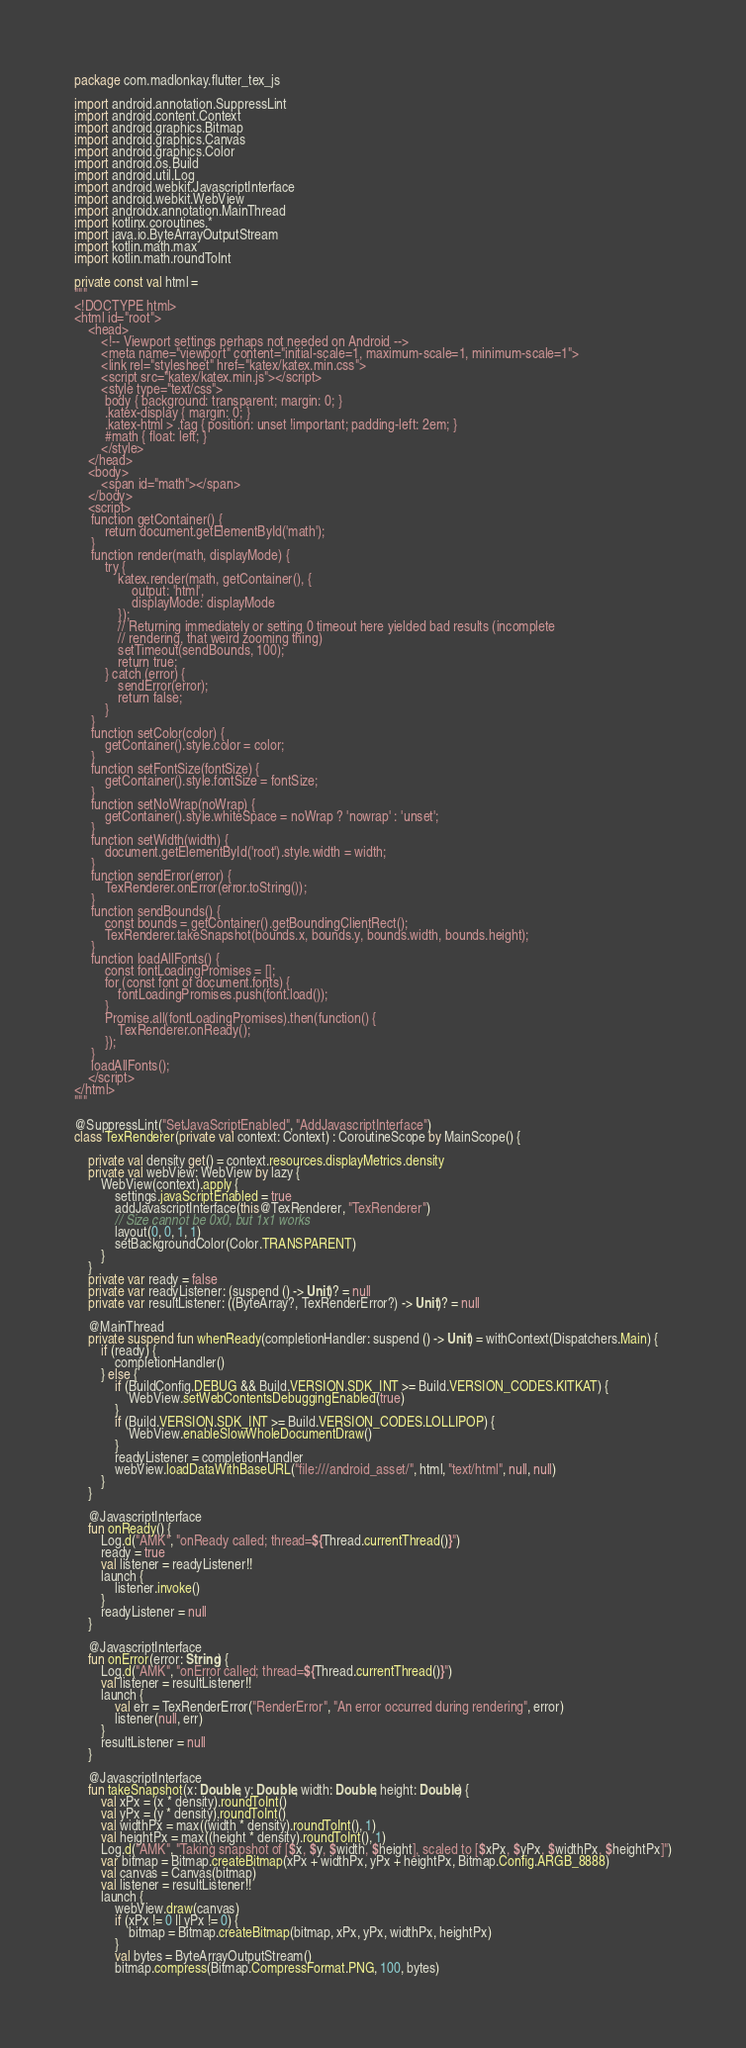<code> <loc_0><loc_0><loc_500><loc_500><_Kotlin_>package com.madlonkay.flutter_tex_js

import android.annotation.SuppressLint
import android.content.Context
import android.graphics.Bitmap
import android.graphics.Canvas
import android.graphics.Color
import android.os.Build
import android.util.Log
import android.webkit.JavascriptInterface
import android.webkit.WebView
import androidx.annotation.MainThread
import kotlinx.coroutines.*
import java.io.ByteArrayOutputStream
import kotlin.math.max
import kotlin.math.roundToInt

private const val html =
"""
<!DOCTYPE html>
<html id="root">
    <head>
        <!-- Viewport settings perhaps not needed on Android -->
        <meta name="viewport" content="initial-scale=1, maximum-scale=1, minimum-scale=1">
        <link rel="stylesheet" href="katex/katex.min.css">
        <script src="katex/katex.min.js"></script>
        <style type="text/css">
         body { background: transparent; margin: 0; }
         .katex-display { margin: 0; }
         .katex-html > .tag { position: unset !important; padding-left: 2em; }
         #math { float: left; }
        </style>
    </head>
    <body>
        <span id="math"></span>
    </body>
    <script>
     function getContainer() {
         return document.getElementById('math');
     }
     function render(math, displayMode) {
         try {
             katex.render(math, getContainer(), {
                 output: 'html',
                 displayMode: displayMode
             });
             // Returning immediately or setting 0 timeout here yielded bad results (incomplete
             // rendering, that weird zooming thing)
             setTimeout(sendBounds, 100);
             return true;
         } catch (error) {
             sendError(error);
             return false;
         }
     }
     function setColor(color) {
         getContainer().style.color = color;
     }
     function setFontSize(fontSize) {
         getContainer().style.fontSize = fontSize;
     }
     function setNoWrap(noWrap) {
         getContainer().style.whiteSpace = noWrap ? 'nowrap' : 'unset';
     }
     function setWidth(width) {
         document.getElementById('root').style.width = width;
     }
     function sendError(error) {
         TexRenderer.onError(error.toString());
     }
     function sendBounds() {
         const bounds = getContainer().getBoundingClientRect();
         TexRenderer.takeSnapshot(bounds.x, bounds.y, bounds.width, bounds.height);
     }
     function loadAllFonts() {
         const fontLoadingPromises = [];
         for (const font of document.fonts) {
             fontLoadingPromises.push(font.load());
         }
         Promise.all(fontLoadingPromises).then(function() {
             TexRenderer.onReady();
         });
     }
     loadAllFonts();
    </script>
</html>
"""

@SuppressLint("SetJavaScriptEnabled", "AddJavascriptInterface")
class TexRenderer(private val context: Context) : CoroutineScope by MainScope() {

    private val density get() = context.resources.displayMetrics.density
    private val webView: WebView by lazy {
        WebView(context).apply {
            settings.javaScriptEnabled = true
            addJavascriptInterface(this@TexRenderer, "TexRenderer")
            // Size cannot be 0x0, but 1x1 works
            layout(0, 0, 1, 1)
            setBackgroundColor(Color.TRANSPARENT)
        }
    }
    private var ready = false
    private var readyListener: (suspend () -> Unit)? = null
    private var resultListener: ((ByteArray?, TexRenderError?) -> Unit)? = null

    @MainThread
    private suspend fun whenReady(completionHandler: suspend () -> Unit) = withContext(Dispatchers.Main) {
        if (ready) {
            completionHandler()
        } else {
            if (BuildConfig.DEBUG && Build.VERSION.SDK_INT >= Build.VERSION_CODES.KITKAT) {
                WebView.setWebContentsDebuggingEnabled(true)
            }
            if (Build.VERSION.SDK_INT >= Build.VERSION_CODES.LOLLIPOP) {
                WebView.enableSlowWholeDocumentDraw()
            }
            readyListener = completionHandler
            webView.loadDataWithBaseURL("file:///android_asset/", html, "text/html", null, null)
        }
    }

    @JavascriptInterface
    fun onReady() {
        Log.d("AMK", "onReady called; thread=${Thread.currentThread()}")
        ready = true
        val listener = readyListener!!
        launch {
            listener.invoke()
        }
        readyListener = null
    }

    @JavascriptInterface
    fun onError(error: String) {
        Log.d("AMK", "onError called; thread=${Thread.currentThread()}")
        val listener = resultListener!!
        launch {
            val err = TexRenderError("RenderError", "An error occurred during rendering", error)
            listener(null, err)
        }
        resultListener = null
    }

    @JavascriptInterface
    fun takeSnapshot(x: Double, y: Double, width: Double, height: Double) {
        val xPx = (x * density).roundToInt()
        val yPx = (y * density).roundToInt()
        val widthPx = max((width * density).roundToInt(), 1)
        val heightPx = max((height * density).roundToInt(), 1)
        Log.d("AMK", "Taking snapshot of [$x, $y, $width, $height], scaled to [$xPx, $yPx, $widthPx, $heightPx]")
        var bitmap = Bitmap.createBitmap(xPx + widthPx, yPx + heightPx, Bitmap.Config.ARGB_8888)
        val canvas = Canvas(bitmap)
        val listener = resultListener!!
        launch {
            webView.draw(canvas)
            if (xPx != 0 || yPx != 0) {
                bitmap = Bitmap.createBitmap(bitmap, xPx, yPx, widthPx, heightPx)
            }
            val bytes = ByteArrayOutputStream()
            bitmap.compress(Bitmap.CompressFormat.PNG, 100, bytes)</code> 